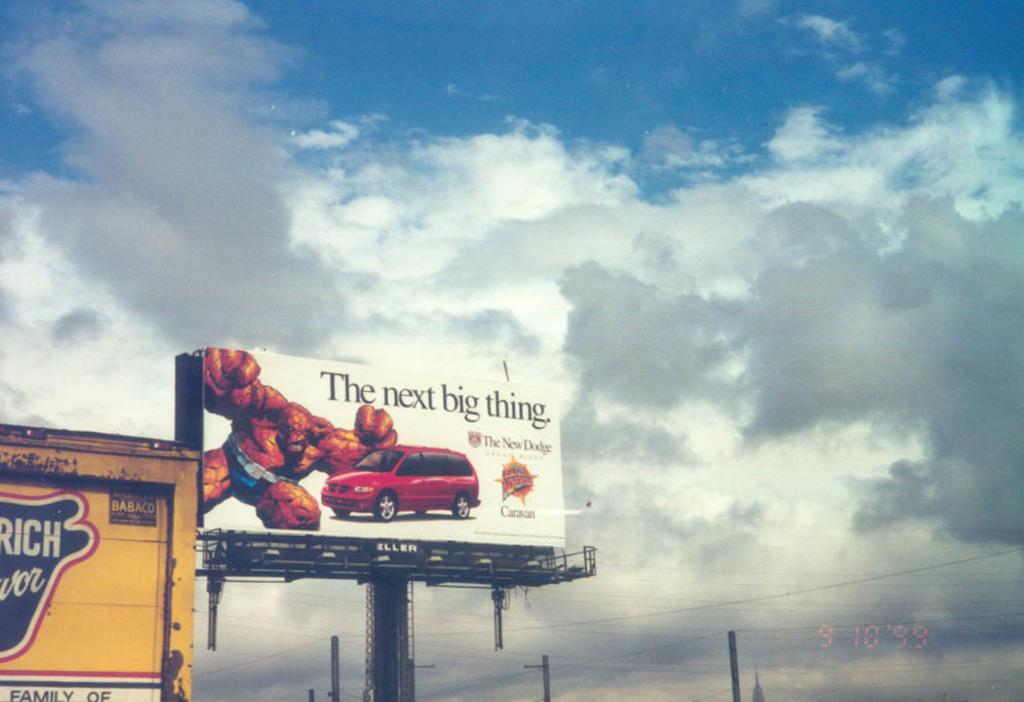This dodge article claims to be what?
Ensure brevity in your answer.  The next big thing. Is the word rich mentioned to the left?
Ensure brevity in your answer.  Yes. 